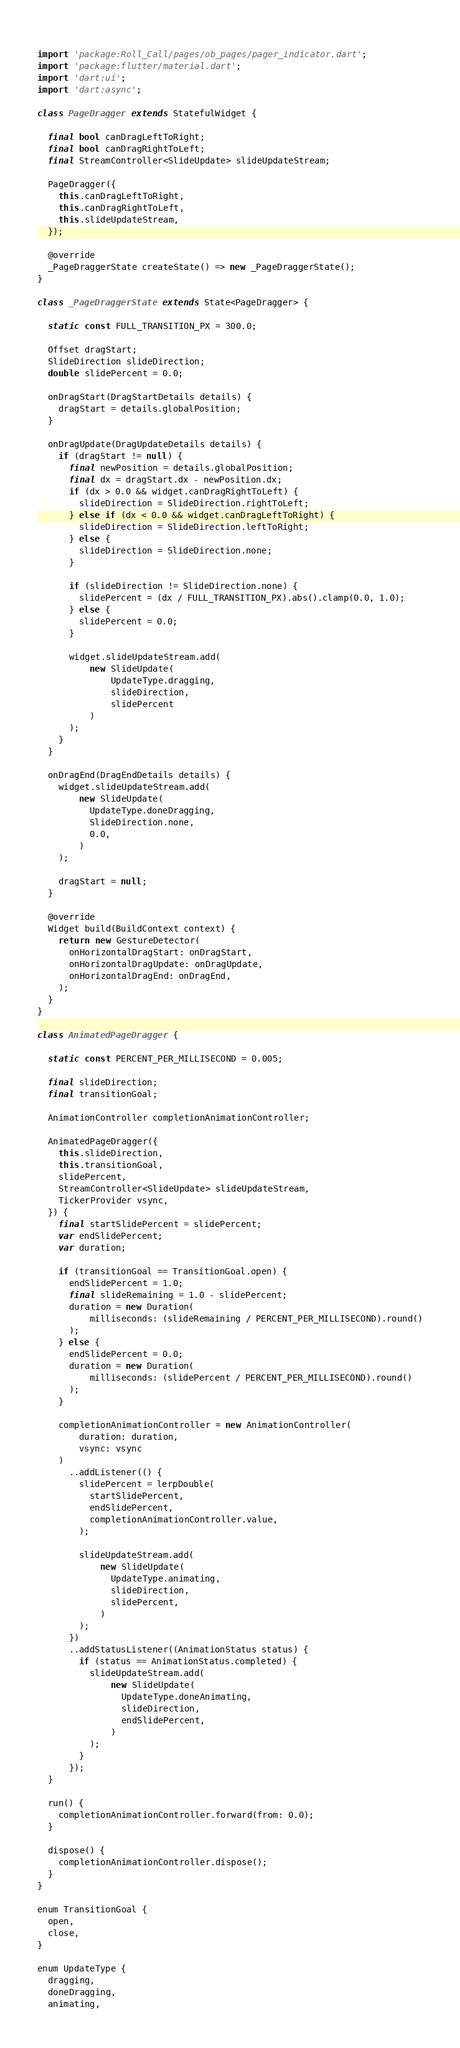<code> <loc_0><loc_0><loc_500><loc_500><_Dart_> 
import 'package:Roll_Call/pages/ob_pages/pager_indicator.dart';
import 'package:flutter/material.dart';
import 'dart:ui';
import 'dart:async';

class PageDragger extends StatefulWidget {

  final bool canDragLeftToRight;
  final bool canDragRightToLeft;
  final StreamController<SlideUpdate> slideUpdateStream;

  PageDragger({
    this.canDragLeftToRight,
    this.canDragRightToLeft,
    this.slideUpdateStream,
  });

  @override
  _PageDraggerState createState() => new _PageDraggerState();
}

class _PageDraggerState extends State<PageDragger> {

  static const FULL_TRANSITION_PX = 300.0;

  Offset dragStart;
  SlideDirection slideDirection;
  double slidePercent = 0.0;

  onDragStart(DragStartDetails details) {
    dragStart = details.globalPosition;
  }

  onDragUpdate(DragUpdateDetails details) {
    if (dragStart != null) {
      final newPosition = details.globalPosition;
      final dx = dragStart.dx - newPosition.dx;
      if (dx > 0.0 && widget.canDragRightToLeft) {
        slideDirection = SlideDirection.rightToLeft;
      } else if (dx < 0.0 && widget.canDragLeftToRight) {
        slideDirection = SlideDirection.leftToRight;
      } else {
        slideDirection = SlideDirection.none;
      }

      if (slideDirection != SlideDirection.none) {
        slidePercent = (dx / FULL_TRANSITION_PX).abs().clamp(0.0, 1.0);
      } else {
        slidePercent = 0.0;
      }

      widget.slideUpdateStream.add(
          new SlideUpdate(
              UpdateType.dragging,
              slideDirection,
              slidePercent
          )
      );
    }
  }

  onDragEnd(DragEndDetails details) {
    widget.slideUpdateStream.add(
        new SlideUpdate(
          UpdateType.doneDragging,
          SlideDirection.none,
          0.0,
        )
    );

    dragStart = null;
  }

  @override
  Widget build(BuildContext context) {
    return new GestureDetector(
      onHorizontalDragStart: onDragStart,
      onHorizontalDragUpdate: onDragUpdate,
      onHorizontalDragEnd: onDragEnd,
    );
  }
}

class AnimatedPageDragger {

  static const PERCENT_PER_MILLISECOND = 0.005;

  final slideDirection;
  final transitionGoal;

  AnimationController completionAnimationController;

  AnimatedPageDragger({
    this.slideDirection,
    this.transitionGoal,
    slidePercent,
    StreamController<SlideUpdate> slideUpdateStream,
    TickerProvider vsync,
  }) {
    final startSlidePercent = slidePercent;
    var endSlidePercent;
    var duration;

    if (transitionGoal == TransitionGoal.open) {
      endSlidePercent = 1.0;
      final slideRemaining = 1.0 - slidePercent;
      duration = new Duration(
          milliseconds: (slideRemaining / PERCENT_PER_MILLISECOND).round()
      );
    } else {
      endSlidePercent = 0.0;
      duration = new Duration(
          milliseconds: (slidePercent / PERCENT_PER_MILLISECOND).round()
      );
    }

    completionAnimationController = new AnimationController(
        duration: duration,
        vsync: vsync
    )
      ..addListener(() {
        slidePercent = lerpDouble(
          startSlidePercent,
          endSlidePercent,
          completionAnimationController.value,
        );

        slideUpdateStream.add(
            new SlideUpdate(
              UpdateType.animating,
              slideDirection,
              slidePercent,
            )
        );
      })
      ..addStatusListener((AnimationStatus status) {
        if (status == AnimationStatus.completed) {
          slideUpdateStream.add(
              new SlideUpdate(
                UpdateType.doneAnimating,
                slideDirection,
                endSlidePercent,
              )
          );
        }
      });
  }

  run() {
    completionAnimationController.forward(from: 0.0);
  }

  dispose() {
    completionAnimationController.dispose();
  }
}

enum TransitionGoal {
  open,
  close,
}

enum UpdateType {
  dragging,
  doneDragging,
  animating,</code> 